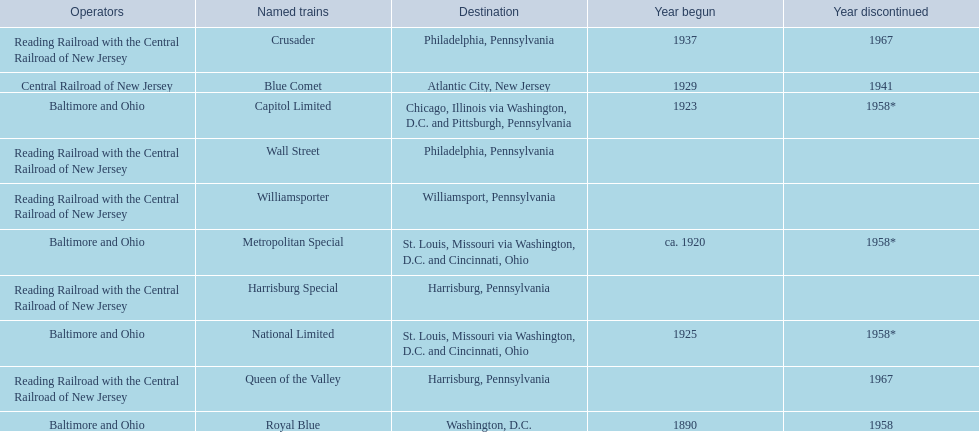Which of the trains are operated by reading railroad with the central railroad of new jersey? Crusader, Harrisburg Special, Queen of the Valley, Wall Street, Williamsporter. Of these trains, which of them had a destination of philadelphia, pennsylvania? Crusader, Wall Street. Out of these two trains, which one is discontinued? Crusader. 